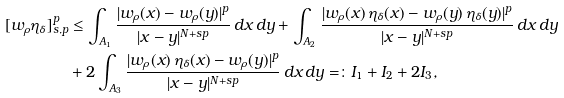<formula> <loc_0><loc_0><loc_500><loc_500>[ w _ { \rho } \eta _ { \delta } ] _ { s , p } ^ { p } & \leq \int _ { A _ { 1 } } \frac { | w _ { \rho } ( x ) - w _ { \rho } ( y ) | ^ { p } } { | x - y | ^ { N + s p } } \, d x \, d y + \int _ { A _ { 2 } } \frac { | w _ { \rho } ( x ) \, \eta _ { \delta } ( x ) - w _ { \rho } ( y ) \, \eta _ { \delta } ( y ) | ^ { p } } { | x - y | ^ { N + s p } } \, d x \, d y \\ & + 2 \int _ { A _ { 3 } } \frac { | w _ { \rho } ( x ) \, \eta _ { \delta } ( x ) - w _ { \rho } ( y ) | ^ { p } } { | x - y | ^ { N + s p } } \, d x \, d y = \colon I _ { 1 } + I _ { 2 } + 2 I _ { 3 } ,</formula> 